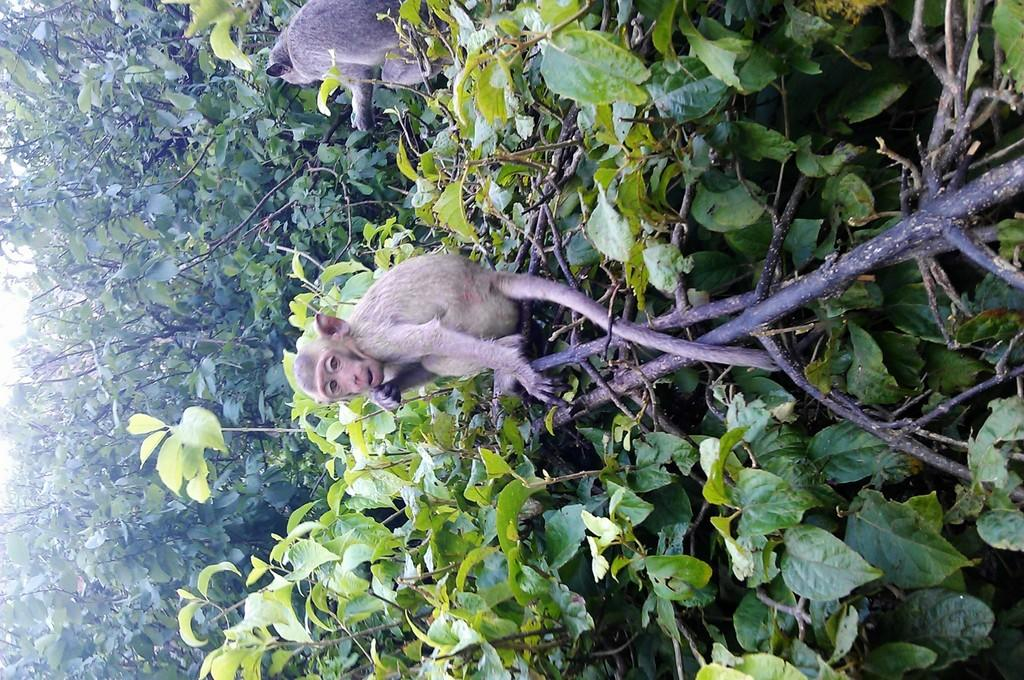How many monkeys are in the image? There are two monkeys in the image. Where are the monkeys located? The monkeys are on trees in the image. What type of vegetation can be seen in the image? Leaves, stems, and branches are visible in the image. What color is the cloth that the monkeys are using to compete in the image? There is no cloth or competition present in the image; it features two monkeys on trees with leaves, stems, and branches visible. 